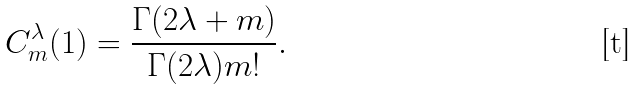Convert formula to latex. <formula><loc_0><loc_0><loc_500><loc_500>C _ { m } ^ { \lambda } ( 1 ) = \frac { \Gamma ( 2 \lambda + m ) } { \Gamma ( 2 \lambda ) m ! } .</formula> 